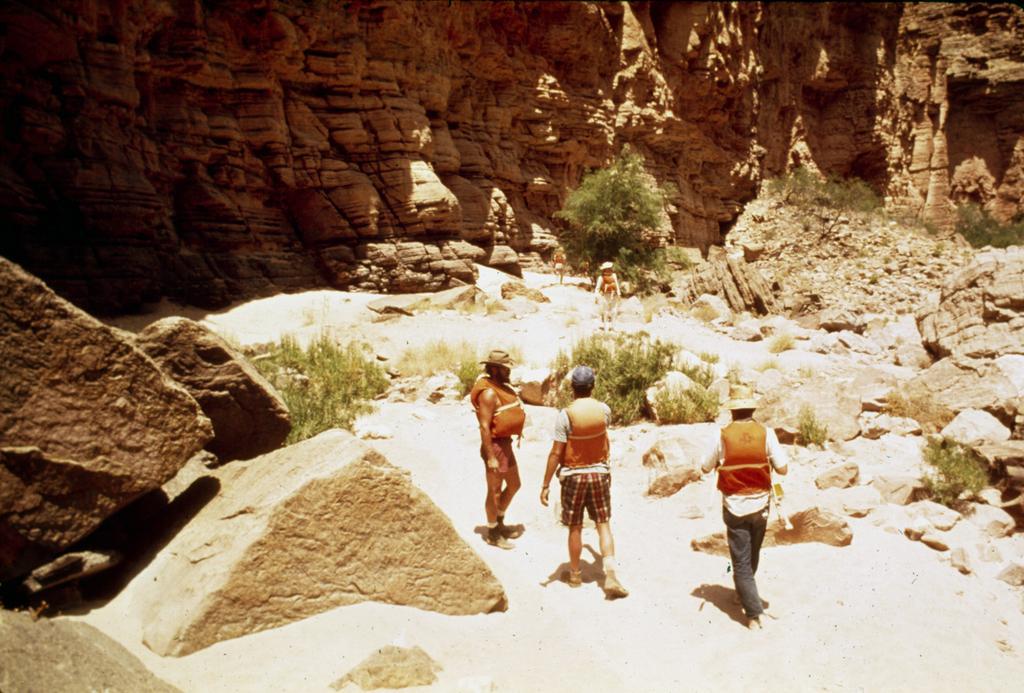Describe this image in one or two sentences. There are three people wearing caps and jacket. There are rocks and plants. In the background there is a rock wall. 